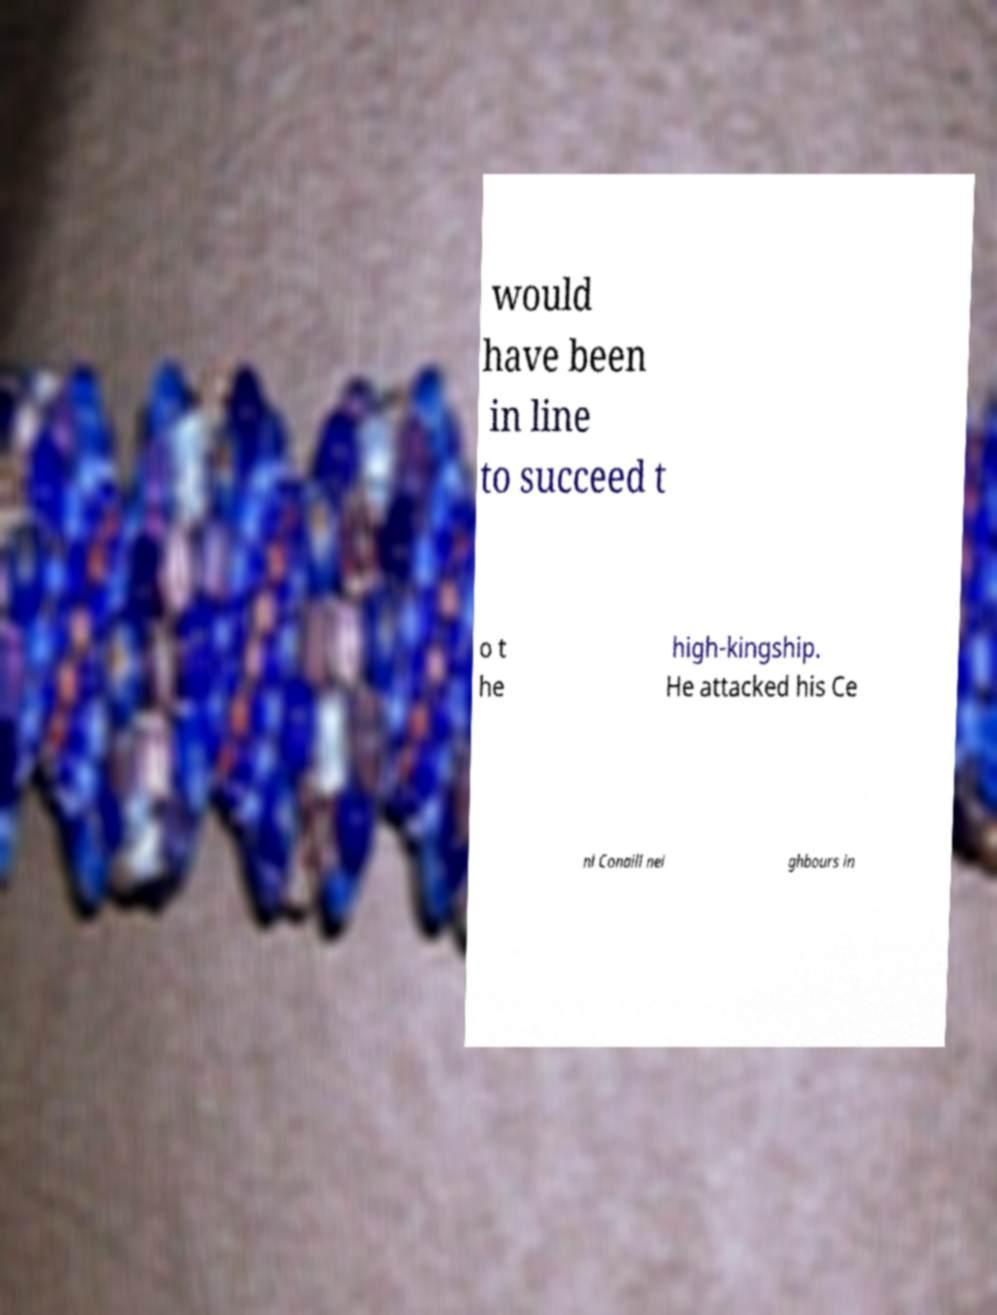Could you assist in decoding the text presented in this image and type it out clearly? would have been in line to succeed t o t he high-kingship. He attacked his Ce nl Conaill nei ghbours in 